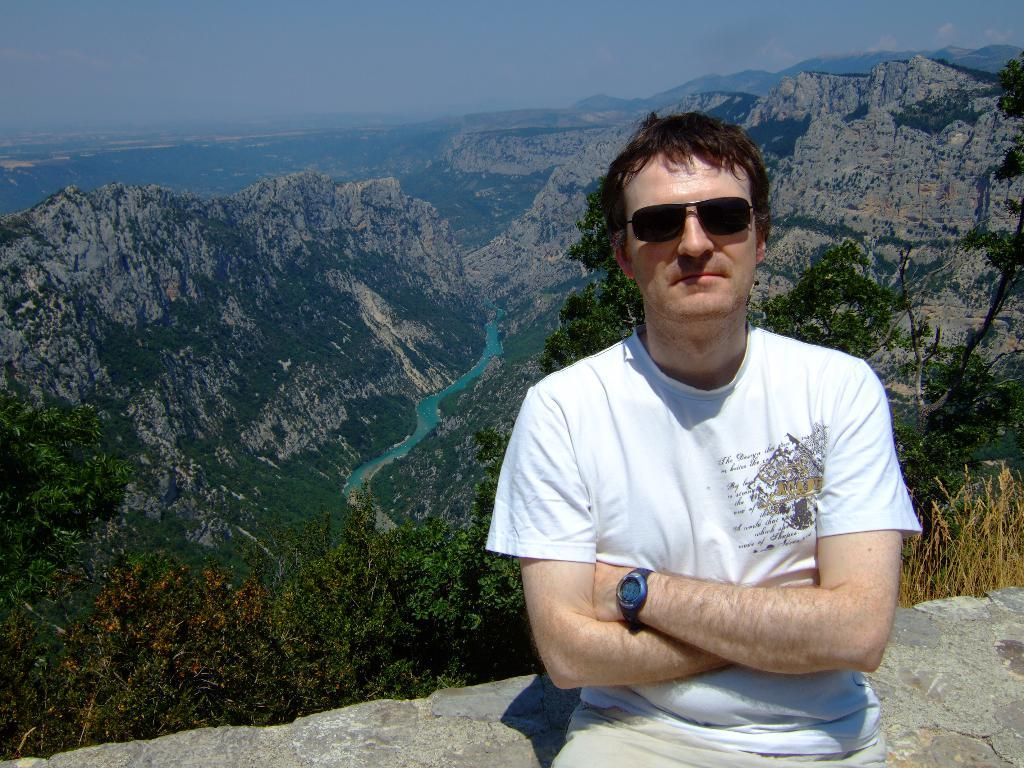What is the person in the image wearing? The person in the image is wearing a white shirt. What can be seen in the distance behind the person? In the background of the image, there are mountains, trees, plants, and water visible. Can you describe the natural environment in the image? The natural environment in the image includes mountains, trees, plants, and water. What type of bun is the person holding in the image? There is no bun present in the image. Can you tell me who the person's uncle is in the image? There is no information about the person's uncle in the image. 